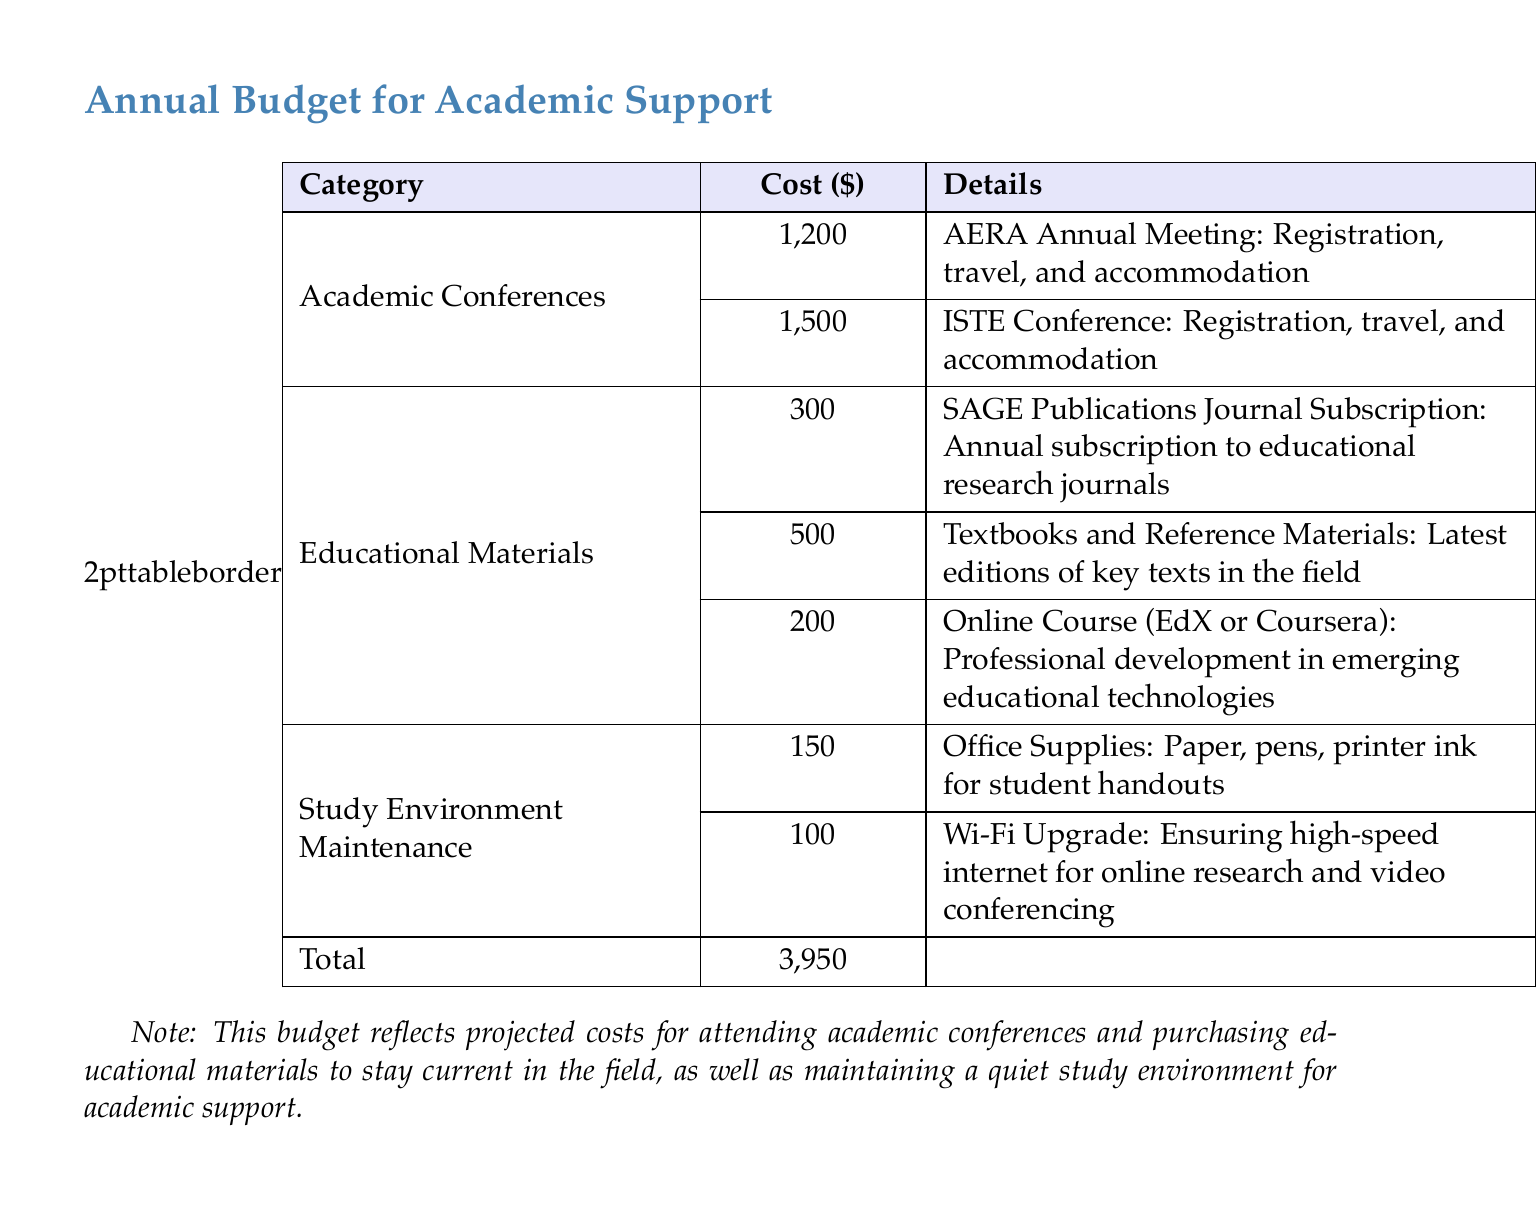What is the total cost projected in the budget? The total cost is presented at the bottom of the budget as the sum of all categories.
Answer: 3,950 How much is allocated for the ISTE Conference? The budget lists the allocation for the ISTE Conference under the Academic Conferences category.
Answer: 1,500 What is the cost for the SAGE Publications Journal Subscription? The budget specifies the cost for the SAGE Publications Journal Subscription under Educational Materials.
Answer: 300 What are the projected costs for office supplies? The budget details the allocation under Study Environment Maintenance, specifically for office supplies.
Answer: 150 How much is budgeted for textbooks and reference materials? The budget includes a line item for the latest editions of key texts under Educational Materials.
Answer: 500 What is the cost for the online course? The budget specifies a cost associated with professional development through an online course.
Answer: 200 What category has the highest total cost? The budget allows comparisons between categories to determine which has the highest allocation.
Answer: Academic Conferences What is the purpose of this budget document? The document includes a note describing the intent behind the projected costs included.
Answer: Academic support and educational materials 